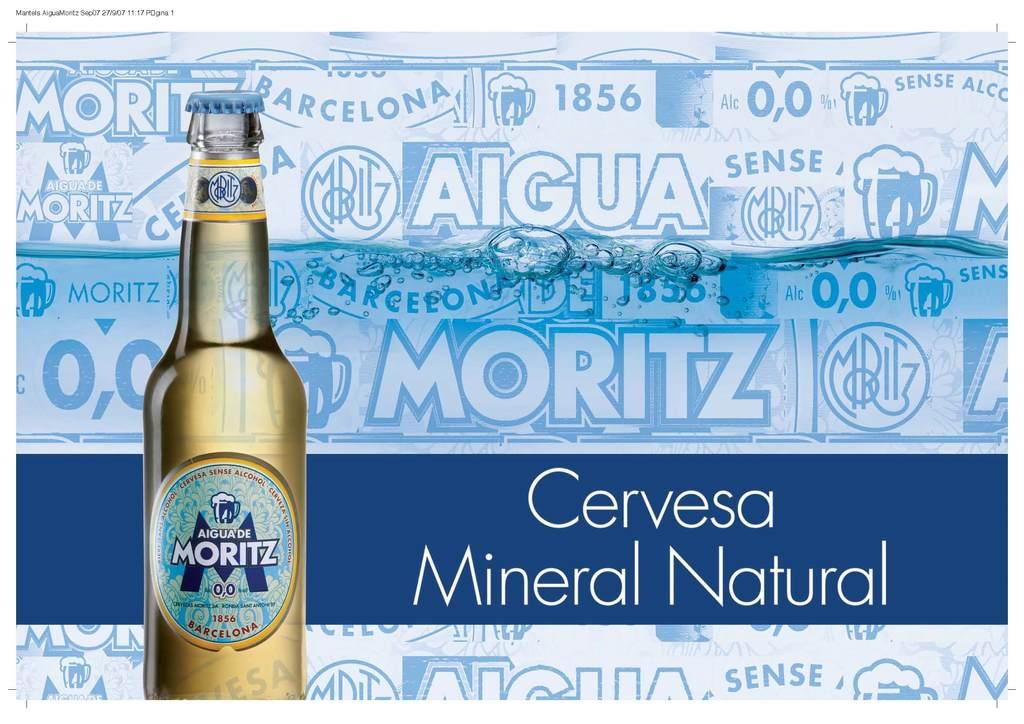<image>
Provide a brief description of the given image. a poster that is promoting cervesa mineral natural 